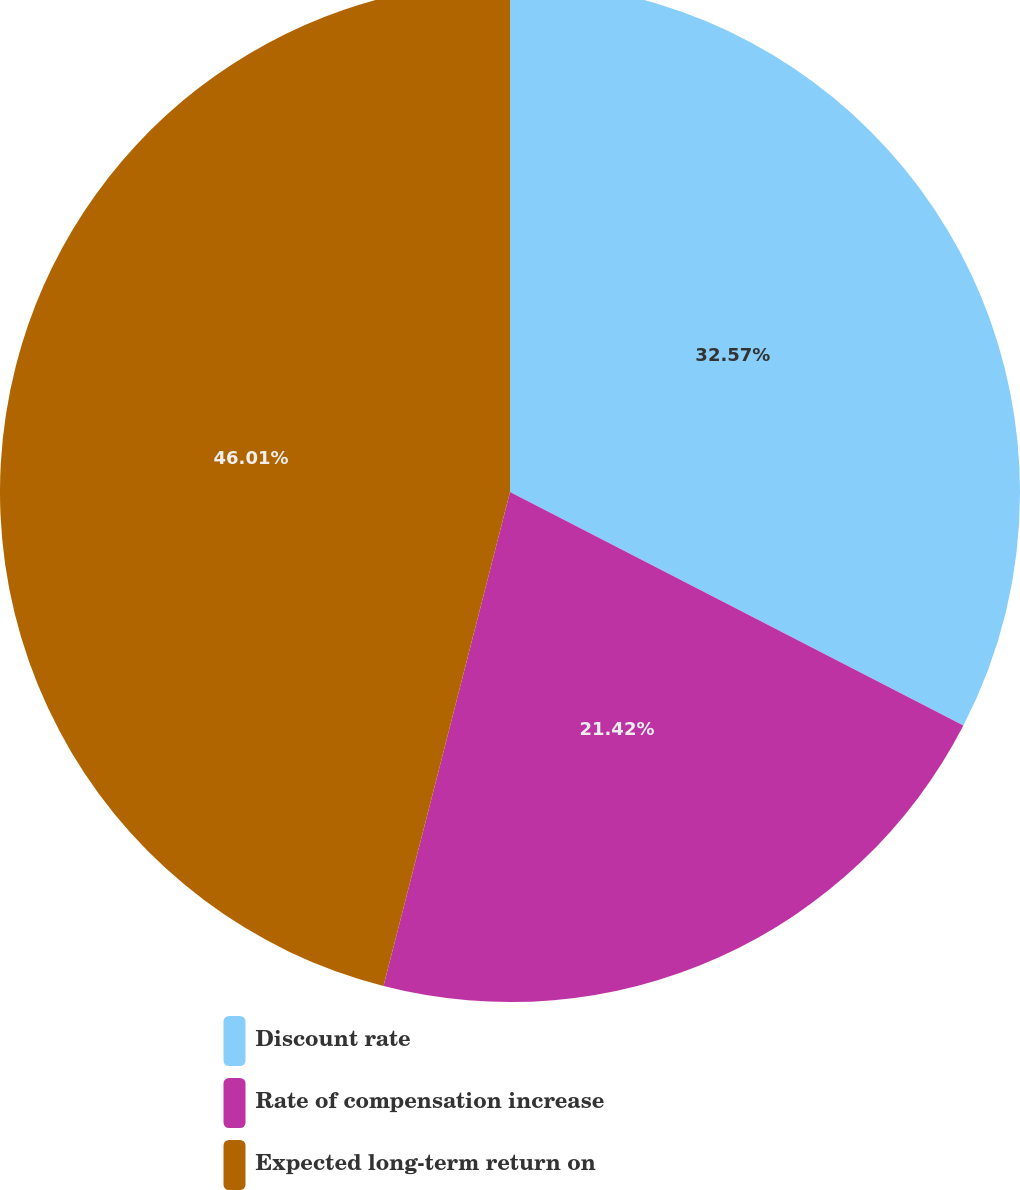Convert chart. <chart><loc_0><loc_0><loc_500><loc_500><pie_chart><fcel>Discount rate<fcel>Rate of compensation increase<fcel>Expected long-term return on<nl><fcel>32.57%<fcel>21.42%<fcel>46.01%<nl></chart> 